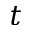Convert formula to latex. <formula><loc_0><loc_0><loc_500><loc_500>t</formula> 